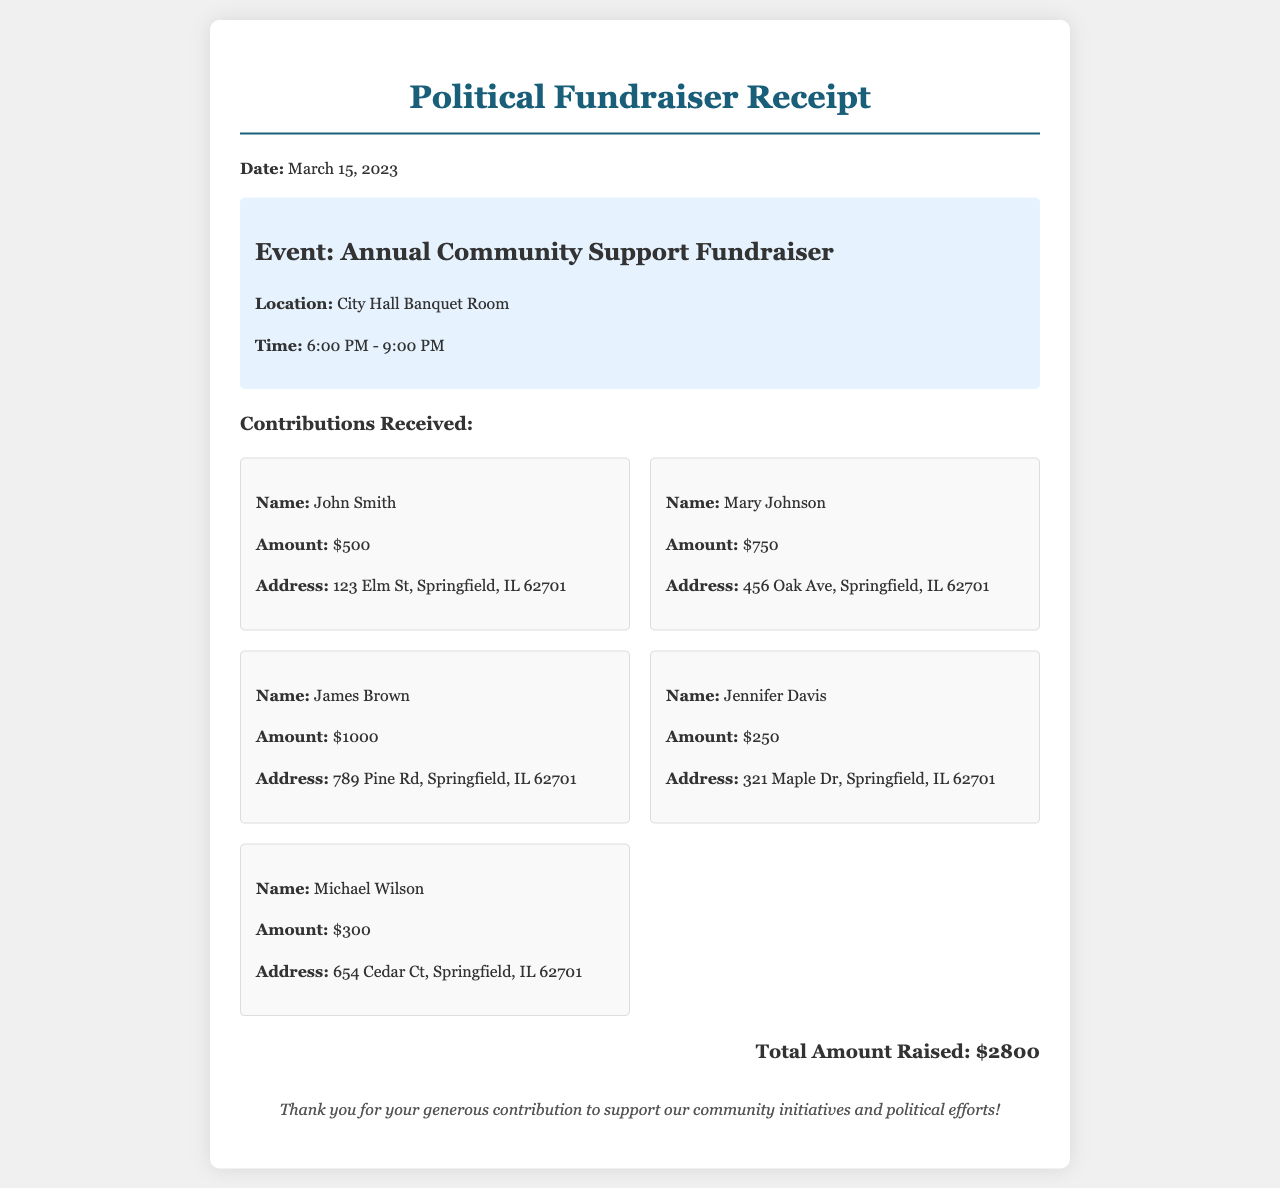What is the date of the fundraiser? The date of the fundraiser is explicitly mentioned in the document as March 15, 2023.
Answer: March 15, 2023 Where was the event held? The location of the event is provided as City Hall Banquet Room in the document.
Answer: City Hall Banquet Room Who donated the highest amount? The donor with the highest contribution is identified as James Brown with a contribution of $1000.
Answer: James Brown What is the total amount raised from the fundraiser? The total amount raised is summarized at the end of the document as $2800.
Answer: $2800 What time did the event start? The starting time of the event is stated as 6:00 PM in the event details section.
Answer: 6:00 PM How many donors are listed in total? The document lists a total of five donors who contributed during the event.
Answer: 5 What is the contribution amount of Mary Johnson? The document states that Mary Johnson contributed an amount of $750.
Answer: $750 What is the purpose of this receipt? The purpose of the receipt is to acknowledge contributions received at a political fundraiser.
Answer: Acknowledge contributions What note is included to the donors at the end of the document? A thank you note expressing gratitude for their generous contributions is included at the end.
Answer: Thank you for your generous contribution 